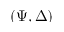Convert formula to latex. <formula><loc_0><loc_0><loc_500><loc_500>\left ( \Psi , \Delta \right )</formula> 